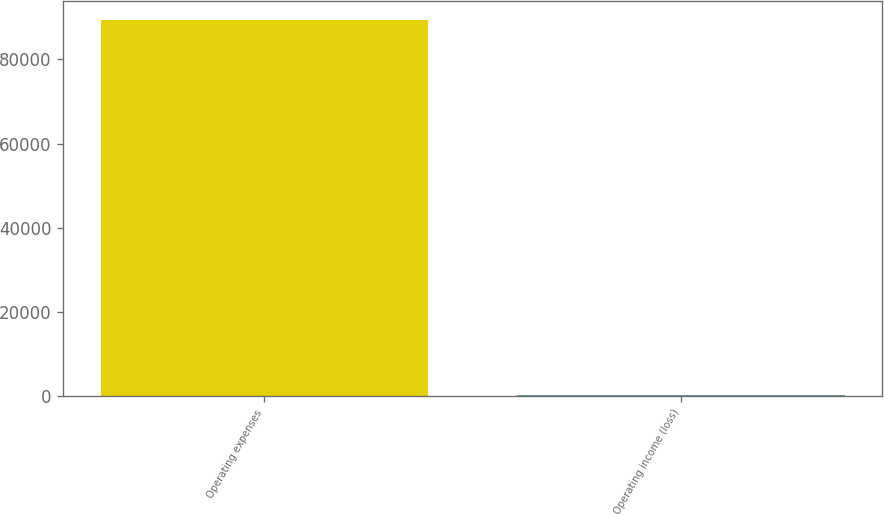Convert chart. <chart><loc_0><loc_0><loc_500><loc_500><bar_chart><fcel>Operating expenses<fcel>Operating income (loss)<nl><fcel>89466<fcel>158<nl></chart> 